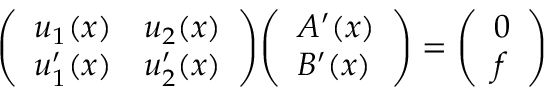<formula> <loc_0><loc_0><loc_500><loc_500>{ \left ( \begin{array} { l l } { u _ { 1 } ( x ) } & { u _ { 2 } ( x ) } \\ { u _ { 1 } ^ { \prime } ( x ) } & { u _ { 2 } ^ { \prime } ( x ) } \end{array} \right ) } { \left ( \begin{array} { l } { A ^ { \prime } ( x ) } \\ { B ^ { \prime } ( x ) } \end{array} \right ) } = { \left ( \begin{array} { l } { 0 } \\ { f } \end{array} \right ) }</formula> 